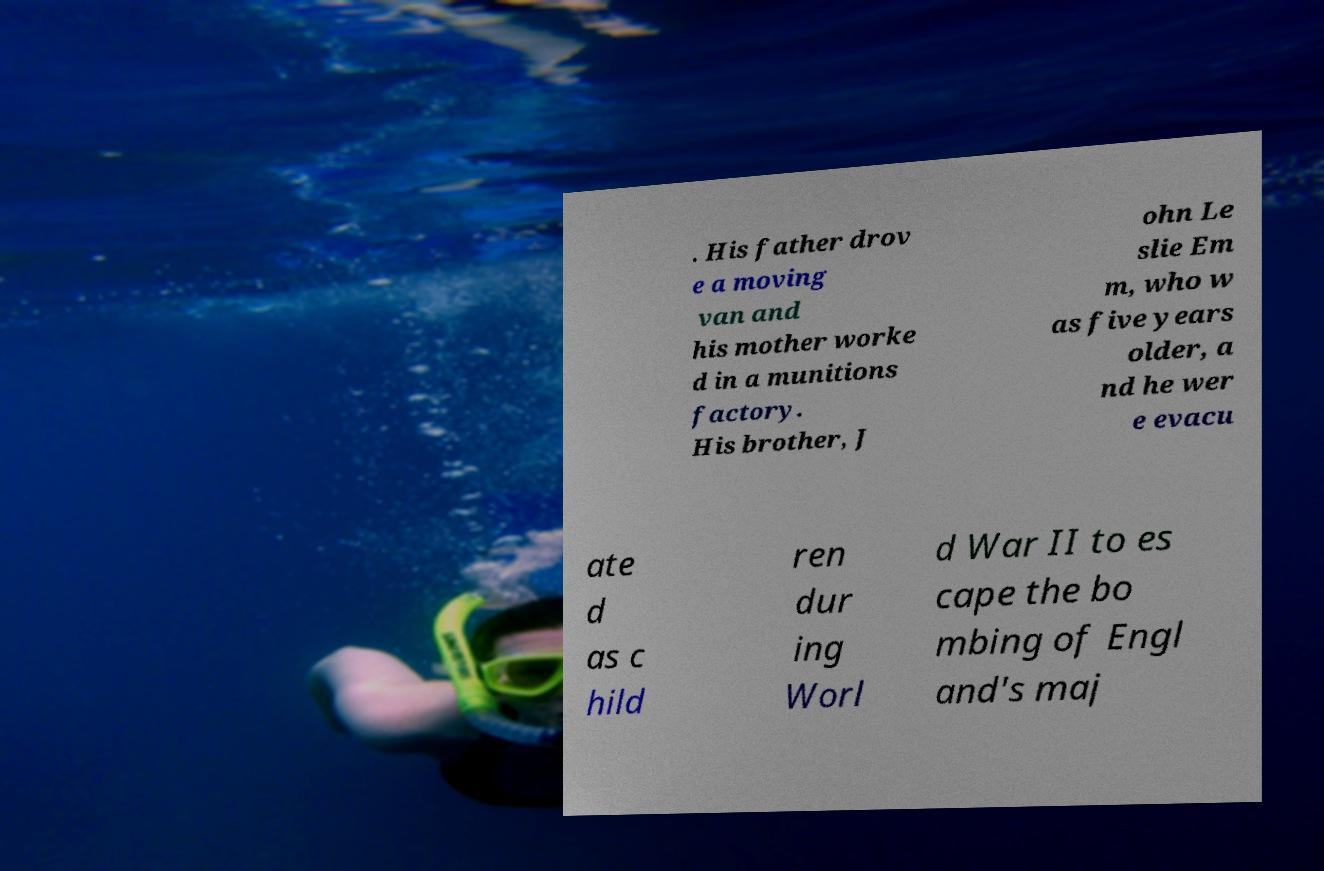Could you extract and type out the text from this image? . His father drov e a moving van and his mother worke d in a munitions factory. His brother, J ohn Le slie Em m, who w as five years older, a nd he wer e evacu ate d as c hild ren dur ing Worl d War II to es cape the bo mbing of Engl and's maj 